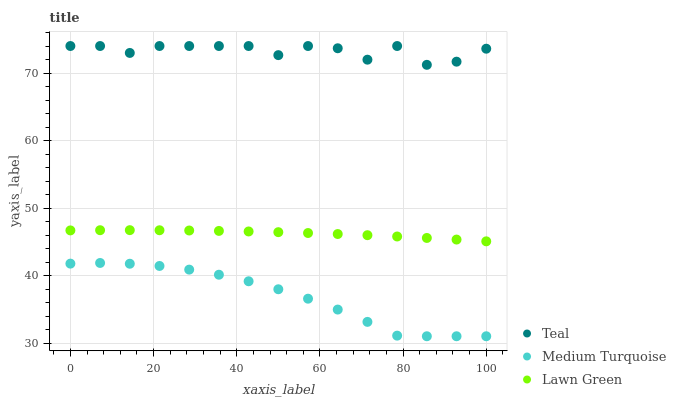Does Medium Turquoise have the minimum area under the curve?
Answer yes or no. Yes. Does Teal have the maximum area under the curve?
Answer yes or no. Yes. Does Teal have the minimum area under the curve?
Answer yes or no. No. Does Medium Turquoise have the maximum area under the curve?
Answer yes or no. No. Is Lawn Green the smoothest?
Answer yes or no. Yes. Is Teal the roughest?
Answer yes or no. Yes. Is Medium Turquoise the smoothest?
Answer yes or no. No. Is Medium Turquoise the roughest?
Answer yes or no. No. Does Medium Turquoise have the lowest value?
Answer yes or no. Yes. Does Teal have the lowest value?
Answer yes or no. No. Does Teal have the highest value?
Answer yes or no. Yes. Does Medium Turquoise have the highest value?
Answer yes or no. No. Is Lawn Green less than Teal?
Answer yes or no. Yes. Is Teal greater than Medium Turquoise?
Answer yes or no. Yes. Does Lawn Green intersect Teal?
Answer yes or no. No. 